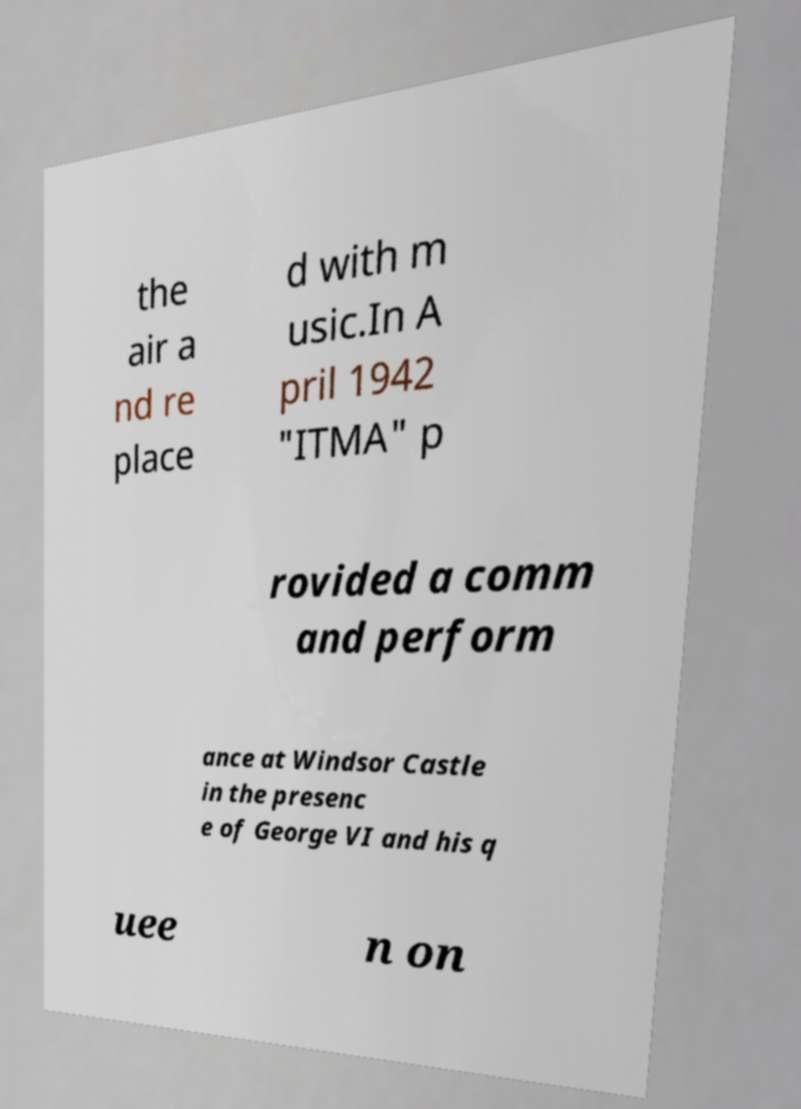Could you extract and type out the text from this image? the air a nd re place d with m usic.In A pril 1942 "ITMA" p rovided a comm and perform ance at Windsor Castle in the presenc e of George VI and his q uee n on 